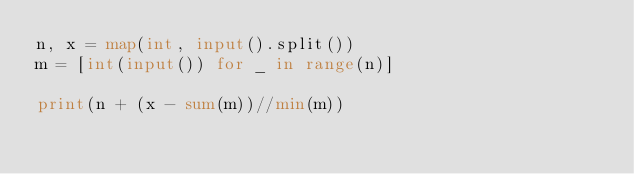Convert code to text. <code><loc_0><loc_0><loc_500><loc_500><_Python_>n, x = map(int, input().split())
m = [int(input()) for _ in range(n)]

print(n + (x - sum(m))//min(m))
</code> 